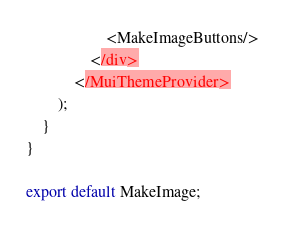<code> <loc_0><loc_0><loc_500><loc_500><_JavaScript_>                    <MakeImageButtons/>
                </div>
            </MuiThemeProvider>
        );
    }
}

export default MakeImage;</code> 